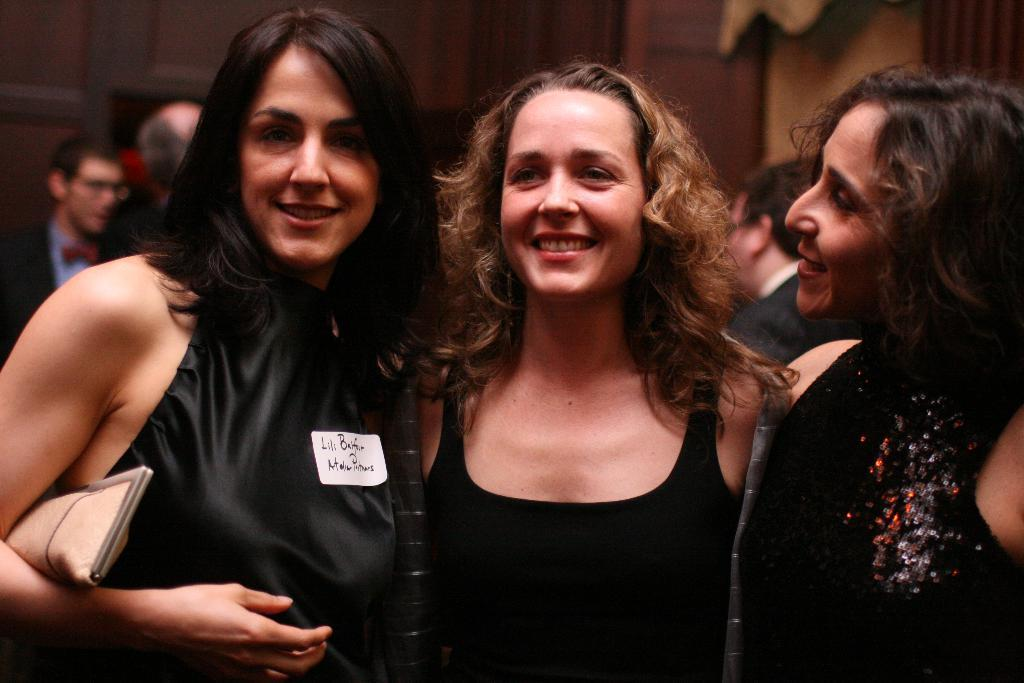Who or what can be seen in the image? There are people in the image. What is present in the background of the image? There is a wall in the image. Can you describe the women in the front of the image? There are three women wearing black color dresses in the front of the image. What type of soda is being served to the boy in the image? There is no boy or soda present in the image. What is the desire of the women in the image? The image does not provide information about the desires of the women. 